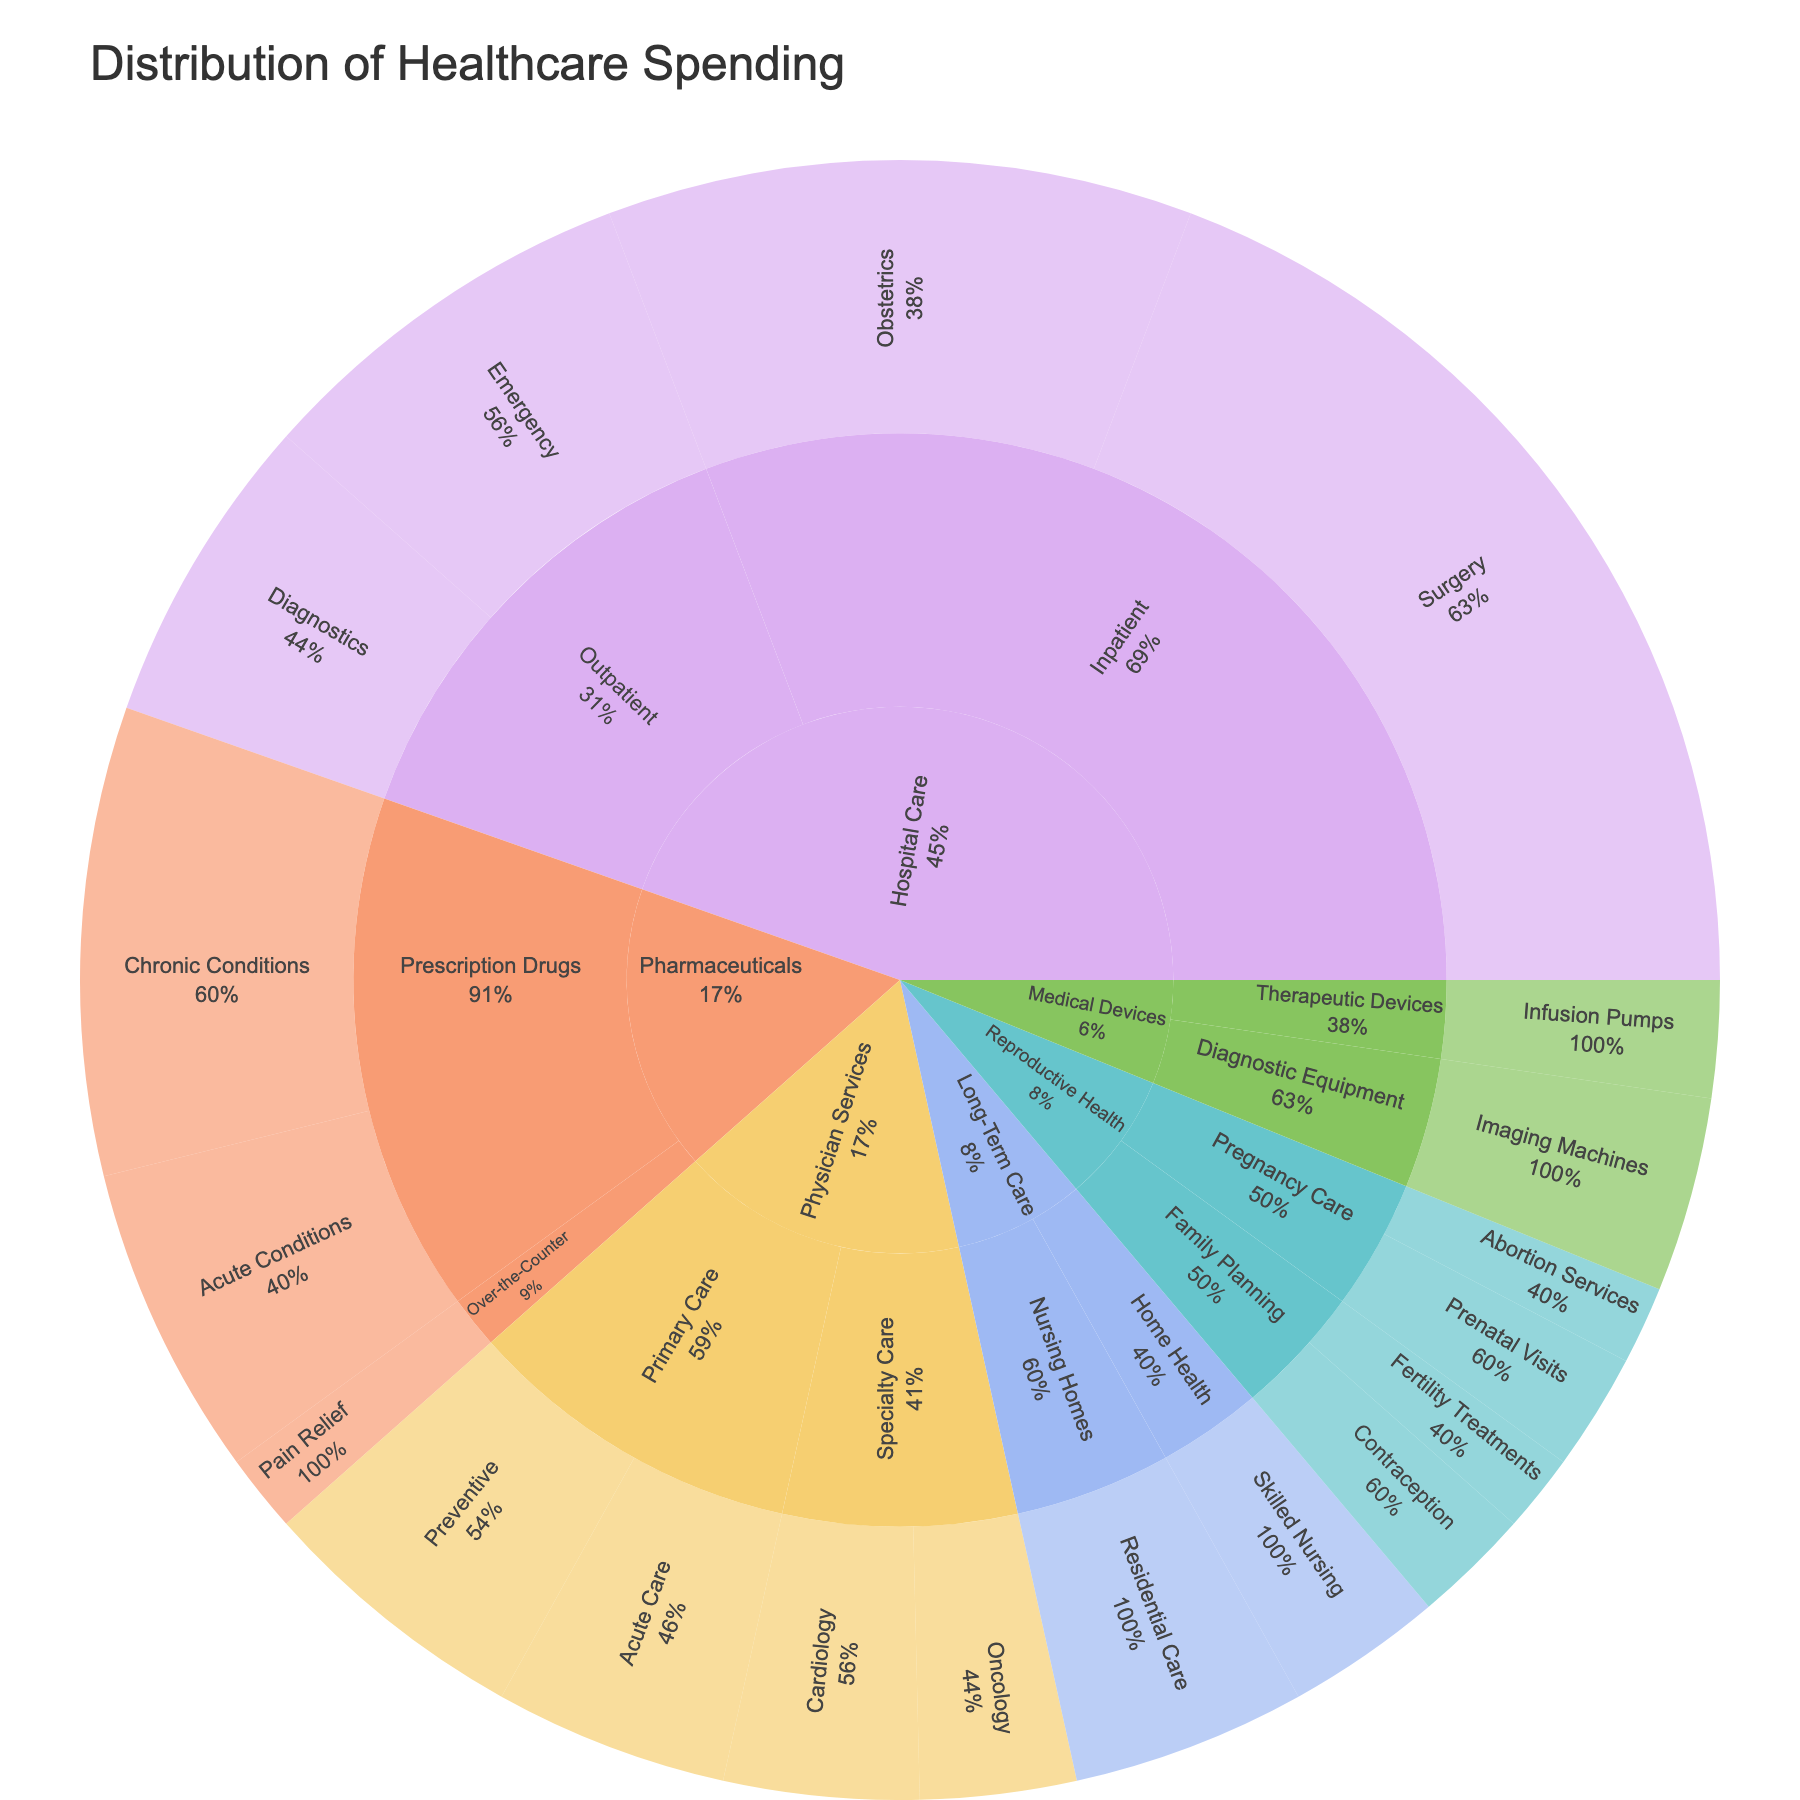What is the title of the plot? The title is located at the top of the plot and it provides an overview of the figure's content, titled "Distribution of Healthcare Spending".
Answer: Distribution of Healthcare Spending Which category has the highest healthcare spending? By looking at the size of the segments, the largest category is "Hospital Care".
Answer: Hospital Care How much is spent on surgery under Hospital Care? Locate the section under "Hospital Care" for "Inpatient" and then find the segment labeled "Surgery"; its value is 25.
Answer: 25 Which subcategory under Hospital Care has the least spending? Under the "Hospital Care" category, compare the sizes and values of the segments for "Inpatient" and "Outpatient"; "Diagnostics" under "Outpatient" has the least spending with a value of 8.
Answer: Outpatient - Diagnostics How does spending on family planning in Reproductive Health compare to surgery in Hospital Care? Compare the combined value of "Family Planning" (Contraception: 3 and Fertility Treatments: 2, total 5) to "Surgery" under "Hospital Care" (value: 25); spending on "Surgery" is higher.
Answer: Surgery in Hospital Care is higher What percentage of total spending does Emergency care under Hospital Care represent? Find "Emergency" under "Outpatient" in "Hospital Care" category, which has a value of 10. Sum all values in the dataset (130). The percentage is (10/130)*100 ≈ 7.69%.
Answer: ≈ 7.69% What is the combined spending on Pharmaceuticals? Locate all segments under "Pharmaceuticals" and sum their values (Chronic Conditions: 12, Acute Conditions: 8, Pain Relief: 2). The combined spending is 12 + 8 + 2 = 22.
Answer: 22 Within Reproductive Health, which procedure has equal spending value? In "Reproductive Health", "Contraception" and "Prenatal Visits" both have a spending value of 3.
Answer: Contraception and Prenatal Visits Is spending higher on Nursing Homes or Skilled Nursing in Long-Term Care? Compare the values under "Long-Term Care"; "Nursing Homes" (value: 6) and "Skilled Nursing" (value: 4). Spending is higher on "Nursing Homes".
Answer: Nursing Homes How does spending on Acute Care in Primary Care compare to Diagnostics in Outpatient? Compare values of "Acute Care" in "Primary Care" (6) within "Physician Services" to "Diagnostics" (8) within "Outpatient" in "Hospital Care". Diagnostics has higher spending.
Answer: Diagnostics in Outpatient is higher 